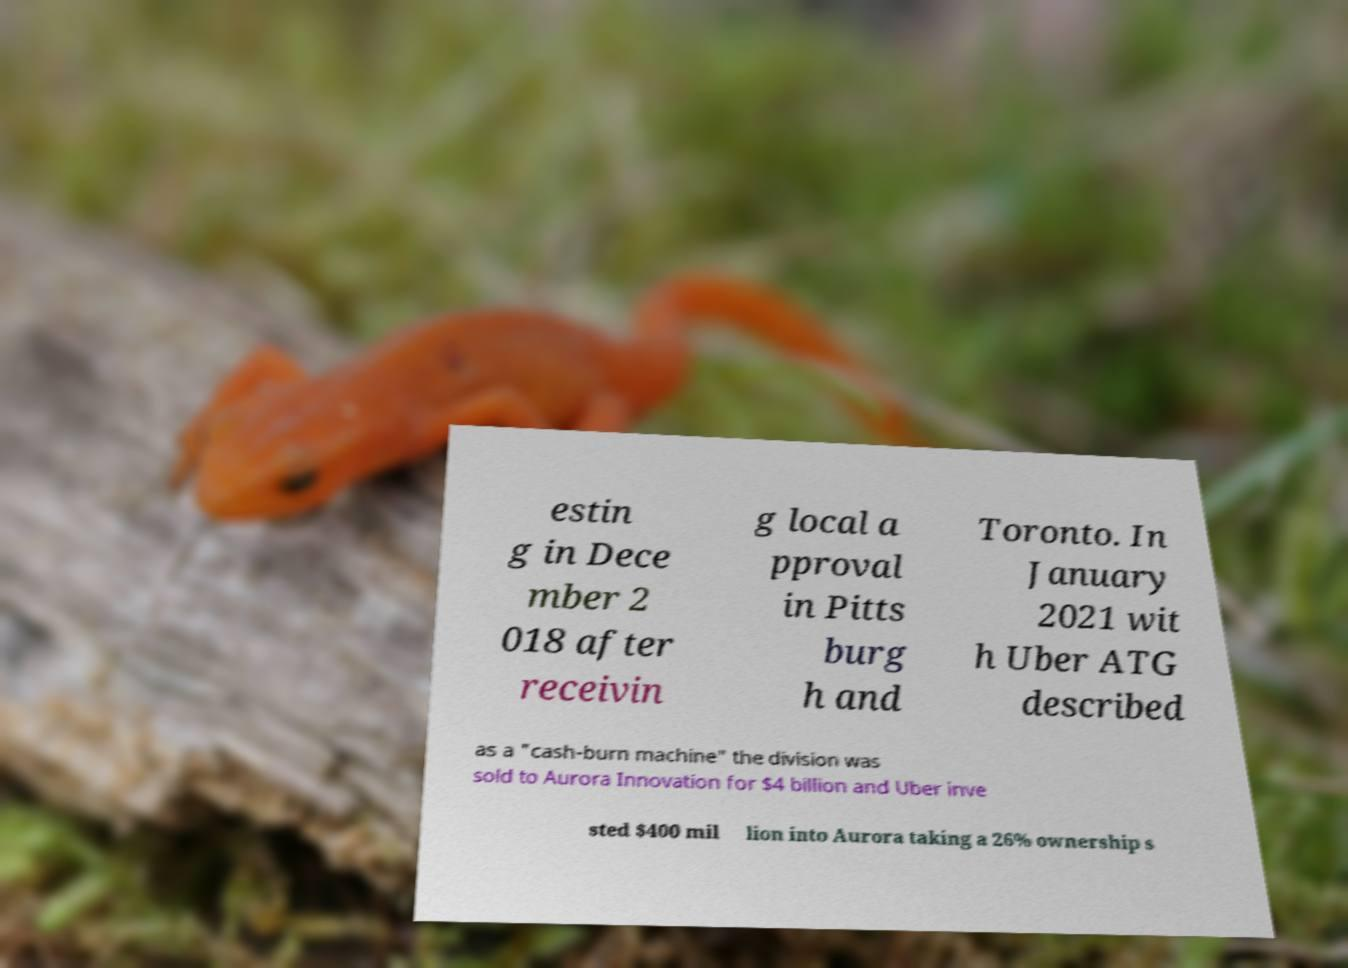Can you accurately transcribe the text from the provided image for me? estin g in Dece mber 2 018 after receivin g local a pproval in Pitts burg h and Toronto. In January 2021 wit h Uber ATG described as a "cash-burn machine" the division was sold to Aurora Innovation for $4 billion and Uber inve sted $400 mil lion into Aurora taking a 26% ownership s 